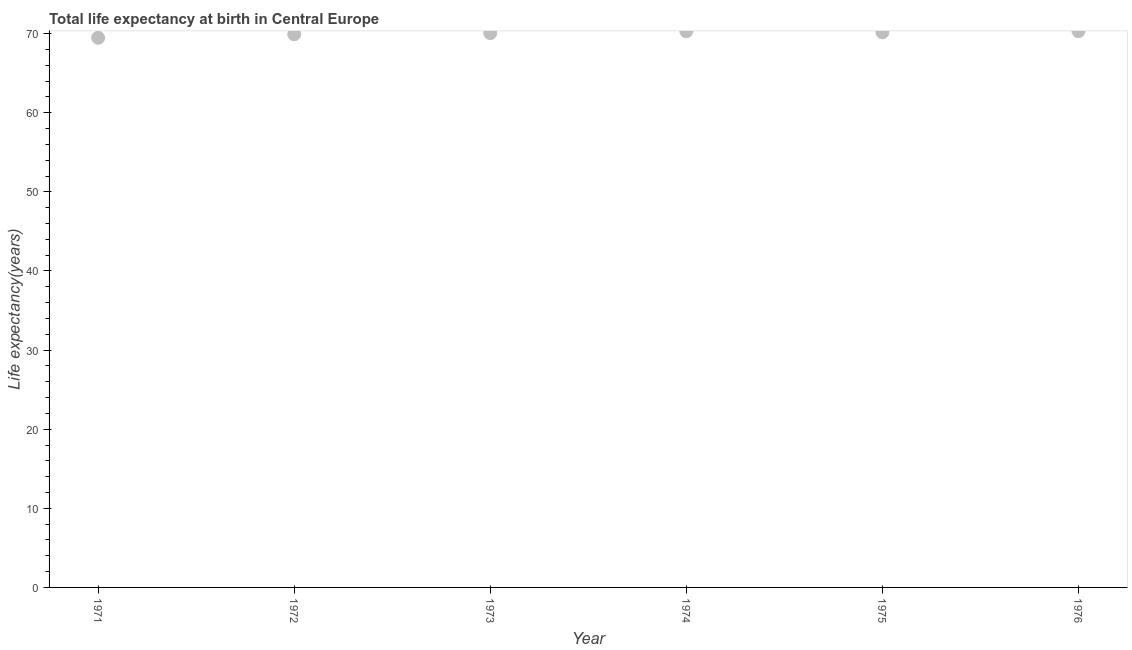What is the life expectancy at birth in 1975?
Your answer should be very brief. 70.17. Across all years, what is the maximum life expectancy at birth?
Provide a succinct answer. 70.32. Across all years, what is the minimum life expectancy at birth?
Ensure brevity in your answer.  69.49. In which year was the life expectancy at birth maximum?
Offer a terse response. 1976. What is the sum of the life expectancy at birth?
Your answer should be compact. 420.28. What is the difference between the life expectancy at birth in 1974 and 1975?
Offer a very short reply. 0.13. What is the average life expectancy at birth per year?
Offer a terse response. 70.05. What is the median life expectancy at birth?
Your response must be concise. 70.12. What is the ratio of the life expectancy at birth in 1972 to that in 1974?
Make the answer very short. 0.99. Is the life expectancy at birth in 1973 less than that in 1976?
Keep it short and to the point. Yes. Is the difference between the life expectancy at birth in 1971 and 1976 greater than the difference between any two years?
Your answer should be very brief. Yes. What is the difference between the highest and the second highest life expectancy at birth?
Ensure brevity in your answer.  0.01. What is the difference between the highest and the lowest life expectancy at birth?
Keep it short and to the point. 0.83. How many dotlines are there?
Offer a very short reply. 1. How many years are there in the graph?
Your answer should be very brief. 6. What is the difference between two consecutive major ticks on the Y-axis?
Provide a short and direct response. 10. What is the title of the graph?
Provide a succinct answer. Total life expectancy at birth in Central Europe. What is the label or title of the Y-axis?
Provide a short and direct response. Life expectancy(years). What is the Life expectancy(years) in 1971?
Make the answer very short. 69.49. What is the Life expectancy(years) in 1972?
Offer a very short reply. 69.93. What is the Life expectancy(years) in 1973?
Offer a terse response. 70.07. What is the Life expectancy(years) in 1974?
Your answer should be very brief. 70.31. What is the Life expectancy(years) in 1975?
Provide a succinct answer. 70.17. What is the Life expectancy(years) in 1976?
Your answer should be compact. 70.32. What is the difference between the Life expectancy(years) in 1971 and 1972?
Give a very brief answer. -0.44. What is the difference between the Life expectancy(years) in 1971 and 1973?
Provide a succinct answer. -0.58. What is the difference between the Life expectancy(years) in 1971 and 1974?
Offer a very short reply. -0.82. What is the difference between the Life expectancy(years) in 1971 and 1975?
Give a very brief answer. -0.69. What is the difference between the Life expectancy(years) in 1971 and 1976?
Provide a succinct answer. -0.83. What is the difference between the Life expectancy(years) in 1972 and 1973?
Ensure brevity in your answer.  -0.14. What is the difference between the Life expectancy(years) in 1972 and 1974?
Make the answer very short. -0.38. What is the difference between the Life expectancy(years) in 1972 and 1975?
Your answer should be very brief. -0.25. What is the difference between the Life expectancy(years) in 1972 and 1976?
Offer a terse response. -0.39. What is the difference between the Life expectancy(years) in 1973 and 1974?
Make the answer very short. -0.24. What is the difference between the Life expectancy(years) in 1973 and 1975?
Offer a terse response. -0.11. What is the difference between the Life expectancy(years) in 1973 and 1976?
Ensure brevity in your answer.  -0.25. What is the difference between the Life expectancy(years) in 1974 and 1975?
Provide a succinct answer. 0.13. What is the difference between the Life expectancy(years) in 1974 and 1976?
Ensure brevity in your answer.  -0.01. What is the difference between the Life expectancy(years) in 1975 and 1976?
Your answer should be compact. -0.14. What is the ratio of the Life expectancy(years) in 1971 to that in 1975?
Make the answer very short. 0.99. What is the ratio of the Life expectancy(years) in 1971 to that in 1976?
Ensure brevity in your answer.  0.99. What is the ratio of the Life expectancy(years) in 1972 to that in 1973?
Provide a succinct answer. 1. What is the ratio of the Life expectancy(years) in 1972 to that in 1975?
Your answer should be compact. 1. What is the ratio of the Life expectancy(years) in 1973 to that in 1975?
Your answer should be very brief. 1. What is the ratio of the Life expectancy(years) in 1974 to that in 1976?
Provide a succinct answer. 1. What is the ratio of the Life expectancy(years) in 1975 to that in 1976?
Your answer should be compact. 1. 